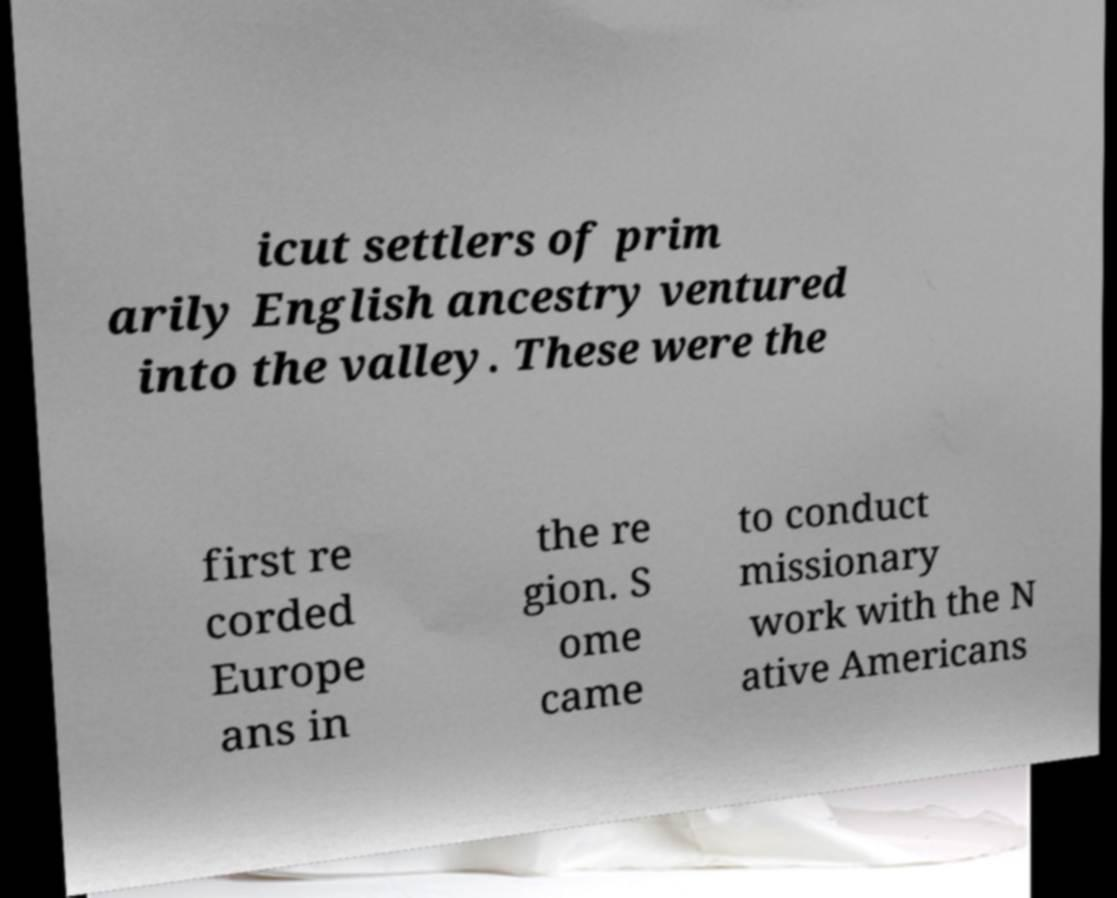Can you accurately transcribe the text from the provided image for me? icut settlers of prim arily English ancestry ventured into the valley. These were the first re corded Europe ans in the re gion. S ome came to conduct missionary work with the N ative Americans 